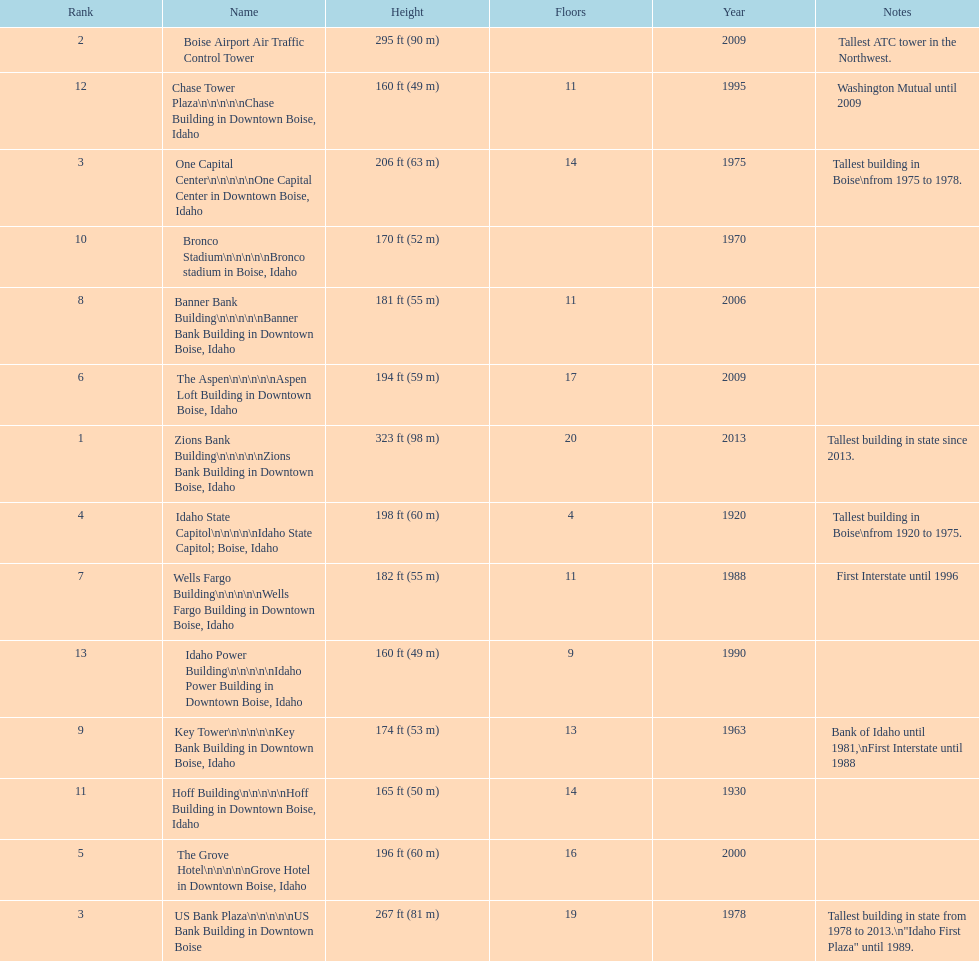Which edifice possesses the greatest amount of floors as per this chart? Zions Bank Building. 